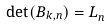<formula> <loc_0><loc_0><loc_500><loc_500>\det ( B _ { k , n } ) = L _ { n } ^ { \text { } }</formula> 